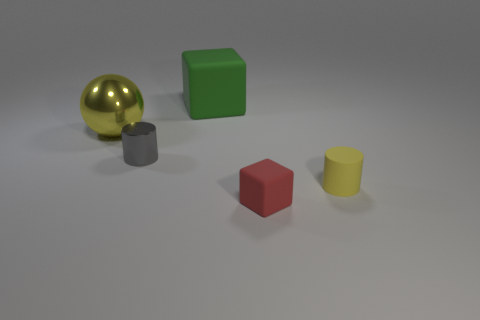Add 2 tiny metal things. How many objects exist? 7 Subtract all green blocks. How many blocks are left? 1 Subtract all spheres. How many objects are left? 4 Add 4 tiny rubber blocks. How many tiny rubber blocks are left? 5 Add 5 green cubes. How many green cubes exist? 6 Subtract 0 brown spheres. How many objects are left? 5 Subtract all big blocks. Subtract all red cubes. How many objects are left? 3 